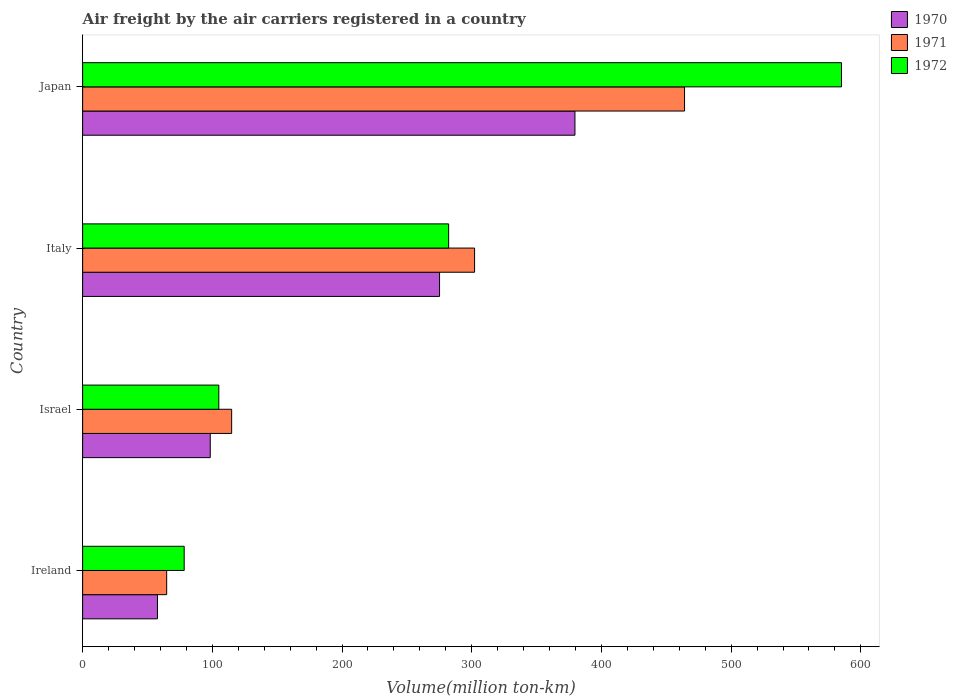Are the number of bars per tick equal to the number of legend labels?
Offer a terse response. Yes. Are the number of bars on each tick of the Y-axis equal?
Ensure brevity in your answer.  Yes. How many bars are there on the 1st tick from the bottom?
Your answer should be very brief. 3. What is the volume of the air carriers in 1970 in Japan?
Offer a very short reply. 379.6. Across all countries, what is the maximum volume of the air carriers in 1971?
Offer a terse response. 464.1. Across all countries, what is the minimum volume of the air carriers in 1972?
Your response must be concise. 78.3. In which country was the volume of the air carriers in 1970 maximum?
Keep it short and to the point. Japan. In which country was the volume of the air carriers in 1972 minimum?
Keep it short and to the point. Ireland. What is the total volume of the air carriers in 1970 in the graph?
Offer a terse response. 810.9. What is the difference between the volume of the air carriers in 1971 in Israel and that in Japan?
Your response must be concise. -349.2. What is the difference between the volume of the air carriers in 1970 in Israel and the volume of the air carriers in 1972 in Japan?
Your answer should be very brief. -486.7. What is the average volume of the air carriers in 1972 per country?
Offer a very short reply. 262.65. What is the difference between the volume of the air carriers in 1972 and volume of the air carriers in 1970 in Japan?
Keep it short and to the point. 205.5. In how many countries, is the volume of the air carriers in 1971 greater than 420 million ton-km?
Provide a succinct answer. 1. What is the ratio of the volume of the air carriers in 1970 in Ireland to that in Israel?
Provide a short and direct response. 0.59. Is the volume of the air carriers in 1970 in Italy less than that in Japan?
Keep it short and to the point. Yes. Is the difference between the volume of the air carriers in 1972 in Ireland and Italy greater than the difference between the volume of the air carriers in 1970 in Ireland and Italy?
Your answer should be compact. Yes. What is the difference between the highest and the second highest volume of the air carriers in 1971?
Your answer should be very brief. 161.9. What is the difference between the highest and the lowest volume of the air carriers in 1972?
Your answer should be compact. 506.8. Is the sum of the volume of the air carriers in 1971 in Israel and Japan greater than the maximum volume of the air carriers in 1972 across all countries?
Ensure brevity in your answer.  No. What does the 2nd bar from the bottom in Ireland represents?
Provide a succinct answer. 1971. Is it the case that in every country, the sum of the volume of the air carriers in 1970 and volume of the air carriers in 1972 is greater than the volume of the air carriers in 1971?
Offer a terse response. Yes. Are all the bars in the graph horizontal?
Your response must be concise. Yes. Are the values on the major ticks of X-axis written in scientific E-notation?
Your answer should be very brief. No. Where does the legend appear in the graph?
Provide a short and direct response. Top right. What is the title of the graph?
Make the answer very short. Air freight by the air carriers registered in a country. Does "1988" appear as one of the legend labels in the graph?
Ensure brevity in your answer.  No. What is the label or title of the X-axis?
Offer a terse response. Volume(million ton-km). What is the Volume(million ton-km) of 1970 in Ireland?
Ensure brevity in your answer.  57.7. What is the Volume(million ton-km) in 1971 in Ireland?
Your answer should be very brief. 64.8. What is the Volume(million ton-km) in 1972 in Ireland?
Your answer should be very brief. 78.3. What is the Volume(million ton-km) of 1970 in Israel?
Your answer should be compact. 98.4. What is the Volume(million ton-km) in 1971 in Israel?
Provide a succinct answer. 114.9. What is the Volume(million ton-km) in 1972 in Israel?
Your response must be concise. 105. What is the Volume(million ton-km) in 1970 in Italy?
Your answer should be very brief. 275.2. What is the Volume(million ton-km) of 1971 in Italy?
Keep it short and to the point. 302.2. What is the Volume(million ton-km) in 1972 in Italy?
Keep it short and to the point. 282.2. What is the Volume(million ton-km) in 1970 in Japan?
Provide a succinct answer. 379.6. What is the Volume(million ton-km) in 1971 in Japan?
Your response must be concise. 464.1. What is the Volume(million ton-km) in 1972 in Japan?
Your answer should be very brief. 585.1. Across all countries, what is the maximum Volume(million ton-km) of 1970?
Keep it short and to the point. 379.6. Across all countries, what is the maximum Volume(million ton-km) of 1971?
Provide a succinct answer. 464.1. Across all countries, what is the maximum Volume(million ton-km) of 1972?
Offer a very short reply. 585.1. Across all countries, what is the minimum Volume(million ton-km) in 1970?
Keep it short and to the point. 57.7. Across all countries, what is the minimum Volume(million ton-km) of 1971?
Give a very brief answer. 64.8. Across all countries, what is the minimum Volume(million ton-km) in 1972?
Your answer should be very brief. 78.3. What is the total Volume(million ton-km) of 1970 in the graph?
Your answer should be very brief. 810.9. What is the total Volume(million ton-km) in 1971 in the graph?
Make the answer very short. 946. What is the total Volume(million ton-km) of 1972 in the graph?
Your answer should be compact. 1050.6. What is the difference between the Volume(million ton-km) in 1970 in Ireland and that in Israel?
Provide a succinct answer. -40.7. What is the difference between the Volume(million ton-km) of 1971 in Ireland and that in Israel?
Offer a terse response. -50.1. What is the difference between the Volume(million ton-km) of 1972 in Ireland and that in Israel?
Give a very brief answer. -26.7. What is the difference between the Volume(million ton-km) of 1970 in Ireland and that in Italy?
Your answer should be compact. -217.5. What is the difference between the Volume(million ton-km) in 1971 in Ireland and that in Italy?
Keep it short and to the point. -237.4. What is the difference between the Volume(million ton-km) of 1972 in Ireland and that in Italy?
Ensure brevity in your answer.  -203.9. What is the difference between the Volume(million ton-km) in 1970 in Ireland and that in Japan?
Offer a very short reply. -321.9. What is the difference between the Volume(million ton-km) of 1971 in Ireland and that in Japan?
Ensure brevity in your answer.  -399.3. What is the difference between the Volume(million ton-km) in 1972 in Ireland and that in Japan?
Your answer should be compact. -506.8. What is the difference between the Volume(million ton-km) of 1970 in Israel and that in Italy?
Your answer should be compact. -176.8. What is the difference between the Volume(million ton-km) in 1971 in Israel and that in Italy?
Give a very brief answer. -187.3. What is the difference between the Volume(million ton-km) of 1972 in Israel and that in Italy?
Your answer should be compact. -177.2. What is the difference between the Volume(million ton-km) in 1970 in Israel and that in Japan?
Offer a very short reply. -281.2. What is the difference between the Volume(million ton-km) of 1971 in Israel and that in Japan?
Ensure brevity in your answer.  -349.2. What is the difference between the Volume(million ton-km) in 1972 in Israel and that in Japan?
Provide a short and direct response. -480.1. What is the difference between the Volume(million ton-km) of 1970 in Italy and that in Japan?
Offer a very short reply. -104.4. What is the difference between the Volume(million ton-km) in 1971 in Italy and that in Japan?
Give a very brief answer. -161.9. What is the difference between the Volume(million ton-km) in 1972 in Italy and that in Japan?
Make the answer very short. -302.9. What is the difference between the Volume(million ton-km) in 1970 in Ireland and the Volume(million ton-km) in 1971 in Israel?
Provide a succinct answer. -57.2. What is the difference between the Volume(million ton-km) of 1970 in Ireland and the Volume(million ton-km) of 1972 in Israel?
Your answer should be compact. -47.3. What is the difference between the Volume(million ton-km) in 1971 in Ireland and the Volume(million ton-km) in 1972 in Israel?
Provide a succinct answer. -40.2. What is the difference between the Volume(million ton-km) in 1970 in Ireland and the Volume(million ton-km) in 1971 in Italy?
Make the answer very short. -244.5. What is the difference between the Volume(million ton-km) of 1970 in Ireland and the Volume(million ton-km) of 1972 in Italy?
Your answer should be very brief. -224.5. What is the difference between the Volume(million ton-km) in 1971 in Ireland and the Volume(million ton-km) in 1972 in Italy?
Your answer should be very brief. -217.4. What is the difference between the Volume(million ton-km) of 1970 in Ireland and the Volume(million ton-km) of 1971 in Japan?
Your answer should be very brief. -406.4. What is the difference between the Volume(million ton-km) of 1970 in Ireland and the Volume(million ton-km) of 1972 in Japan?
Provide a succinct answer. -527.4. What is the difference between the Volume(million ton-km) in 1971 in Ireland and the Volume(million ton-km) in 1972 in Japan?
Your response must be concise. -520.3. What is the difference between the Volume(million ton-km) of 1970 in Israel and the Volume(million ton-km) of 1971 in Italy?
Keep it short and to the point. -203.8. What is the difference between the Volume(million ton-km) in 1970 in Israel and the Volume(million ton-km) in 1972 in Italy?
Keep it short and to the point. -183.8. What is the difference between the Volume(million ton-km) of 1971 in Israel and the Volume(million ton-km) of 1972 in Italy?
Your answer should be compact. -167.3. What is the difference between the Volume(million ton-km) of 1970 in Israel and the Volume(million ton-km) of 1971 in Japan?
Offer a terse response. -365.7. What is the difference between the Volume(million ton-km) of 1970 in Israel and the Volume(million ton-km) of 1972 in Japan?
Your answer should be very brief. -486.7. What is the difference between the Volume(million ton-km) of 1971 in Israel and the Volume(million ton-km) of 1972 in Japan?
Provide a short and direct response. -470.2. What is the difference between the Volume(million ton-km) in 1970 in Italy and the Volume(million ton-km) in 1971 in Japan?
Make the answer very short. -188.9. What is the difference between the Volume(million ton-km) of 1970 in Italy and the Volume(million ton-km) of 1972 in Japan?
Your response must be concise. -309.9. What is the difference between the Volume(million ton-km) of 1971 in Italy and the Volume(million ton-km) of 1972 in Japan?
Give a very brief answer. -282.9. What is the average Volume(million ton-km) of 1970 per country?
Provide a succinct answer. 202.72. What is the average Volume(million ton-km) in 1971 per country?
Ensure brevity in your answer.  236.5. What is the average Volume(million ton-km) in 1972 per country?
Your answer should be very brief. 262.65. What is the difference between the Volume(million ton-km) in 1970 and Volume(million ton-km) in 1972 in Ireland?
Ensure brevity in your answer.  -20.6. What is the difference between the Volume(million ton-km) in 1970 and Volume(million ton-km) in 1971 in Israel?
Your answer should be very brief. -16.5. What is the difference between the Volume(million ton-km) of 1970 and Volume(million ton-km) of 1971 in Italy?
Provide a short and direct response. -27. What is the difference between the Volume(million ton-km) in 1971 and Volume(million ton-km) in 1972 in Italy?
Your answer should be very brief. 20. What is the difference between the Volume(million ton-km) in 1970 and Volume(million ton-km) in 1971 in Japan?
Provide a succinct answer. -84.5. What is the difference between the Volume(million ton-km) in 1970 and Volume(million ton-km) in 1972 in Japan?
Give a very brief answer. -205.5. What is the difference between the Volume(million ton-km) in 1971 and Volume(million ton-km) in 1972 in Japan?
Make the answer very short. -121. What is the ratio of the Volume(million ton-km) in 1970 in Ireland to that in Israel?
Your answer should be very brief. 0.59. What is the ratio of the Volume(million ton-km) in 1971 in Ireland to that in Israel?
Provide a succinct answer. 0.56. What is the ratio of the Volume(million ton-km) of 1972 in Ireland to that in Israel?
Your answer should be very brief. 0.75. What is the ratio of the Volume(million ton-km) of 1970 in Ireland to that in Italy?
Offer a terse response. 0.21. What is the ratio of the Volume(million ton-km) in 1971 in Ireland to that in Italy?
Give a very brief answer. 0.21. What is the ratio of the Volume(million ton-km) of 1972 in Ireland to that in Italy?
Offer a terse response. 0.28. What is the ratio of the Volume(million ton-km) in 1970 in Ireland to that in Japan?
Keep it short and to the point. 0.15. What is the ratio of the Volume(million ton-km) in 1971 in Ireland to that in Japan?
Give a very brief answer. 0.14. What is the ratio of the Volume(million ton-km) in 1972 in Ireland to that in Japan?
Ensure brevity in your answer.  0.13. What is the ratio of the Volume(million ton-km) of 1970 in Israel to that in Italy?
Provide a short and direct response. 0.36. What is the ratio of the Volume(million ton-km) of 1971 in Israel to that in Italy?
Provide a short and direct response. 0.38. What is the ratio of the Volume(million ton-km) of 1972 in Israel to that in Italy?
Your response must be concise. 0.37. What is the ratio of the Volume(million ton-km) in 1970 in Israel to that in Japan?
Ensure brevity in your answer.  0.26. What is the ratio of the Volume(million ton-km) in 1971 in Israel to that in Japan?
Give a very brief answer. 0.25. What is the ratio of the Volume(million ton-km) in 1972 in Israel to that in Japan?
Give a very brief answer. 0.18. What is the ratio of the Volume(million ton-km) of 1970 in Italy to that in Japan?
Your answer should be very brief. 0.72. What is the ratio of the Volume(million ton-km) of 1971 in Italy to that in Japan?
Make the answer very short. 0.65. What is the ratio of the Volume(million ton-km) in 1972 in Italy to that in Japan?
Give a very brief answer. 0.48. What is the difference between the highest and the second highest Volume(million ton-km) in 1970?
Give a very brief answer. 104.4. What is the difference between the highest and the second highest Volume(million ton-km) in 1971?
Your response must be concise. 161.9. What is the difference between the highest and the second highest Volume(million ton-km) in 1972?
Keep it short and to the point. 302.9. What is the difference between the highest and the lowest Volume(million ton-km) of 1970?
Ensure brevity in your answer.  321.9. What is the difference between the highest and the lowest Volume(million ton-km) of 1971?
Offer a terse response. 399.3. What is the difference between the highest and the lowest Volume(million ton-km) in 1972?
Ensure brevity in your answer.  506.8. 